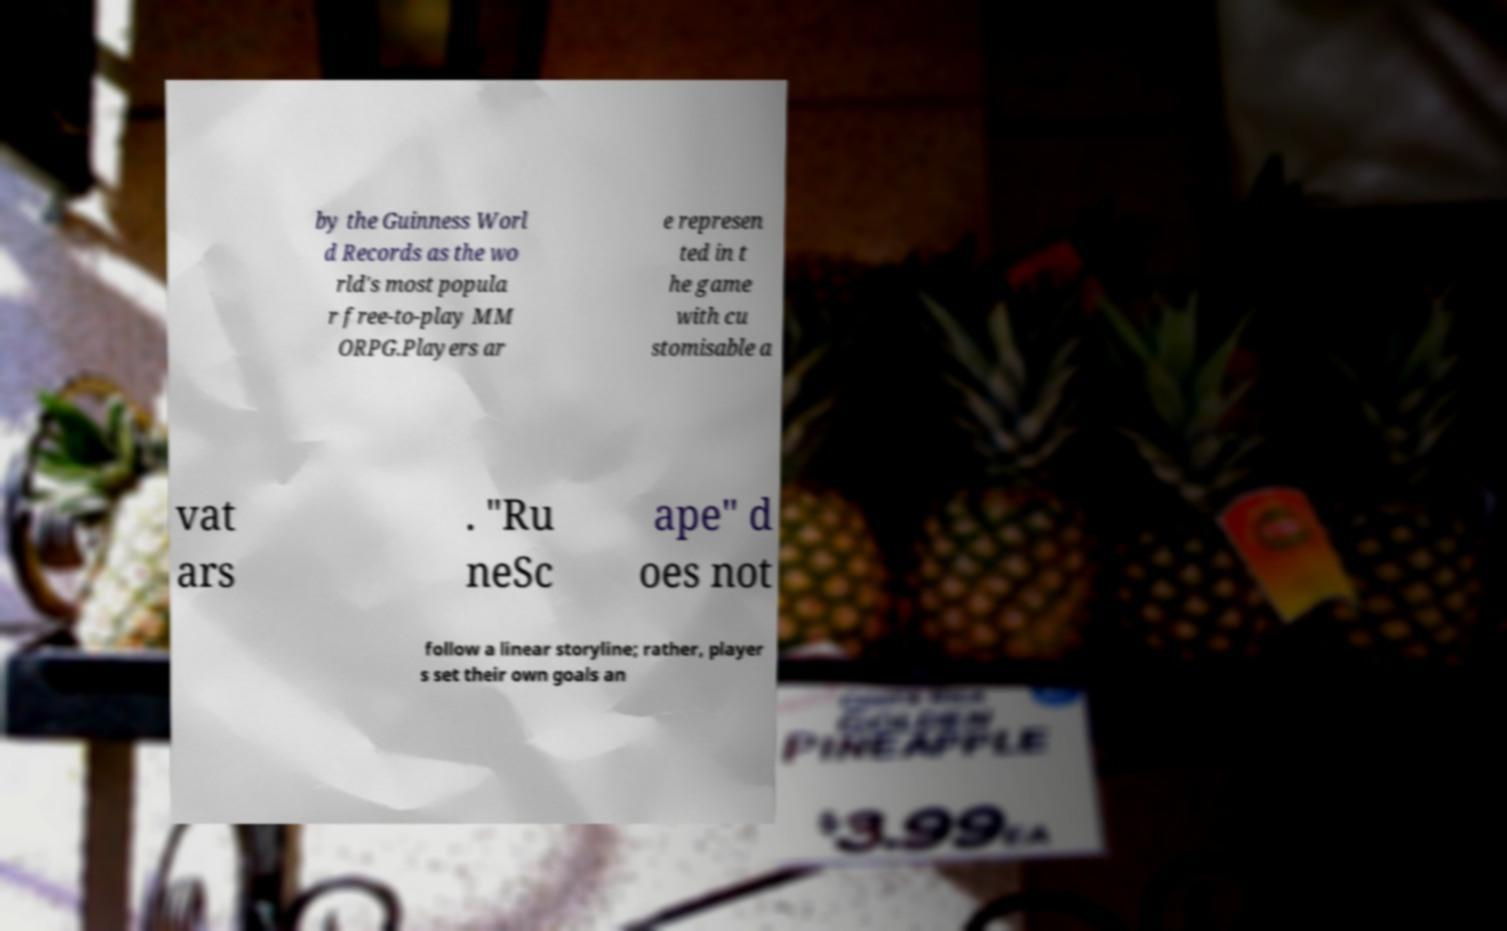Can you accurately transcribe the text from the provided image for me? by the Guinness Worl d Records as the wo rld's most popula r free-to-play MM ORPG.Players ar e represen ted in t he game with cu stomisable a vat ars . "Ru neSc ape" d oes not follow a linear storyline; rather, player s set their own goals an 